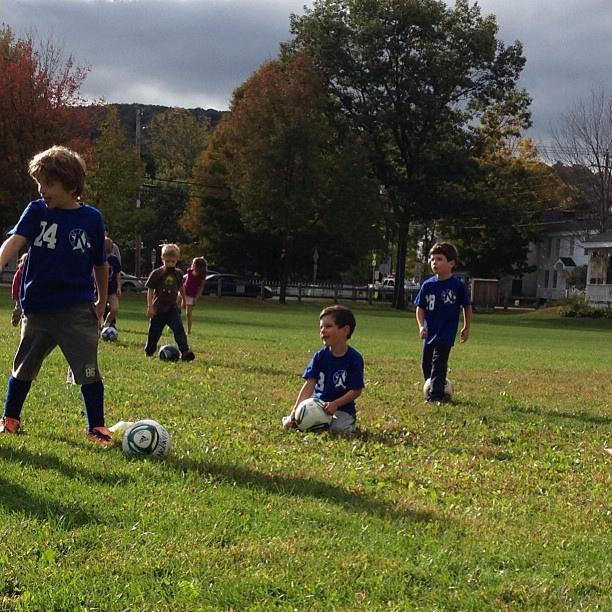How many people can be seen?
Give a very brief answer. 4. 